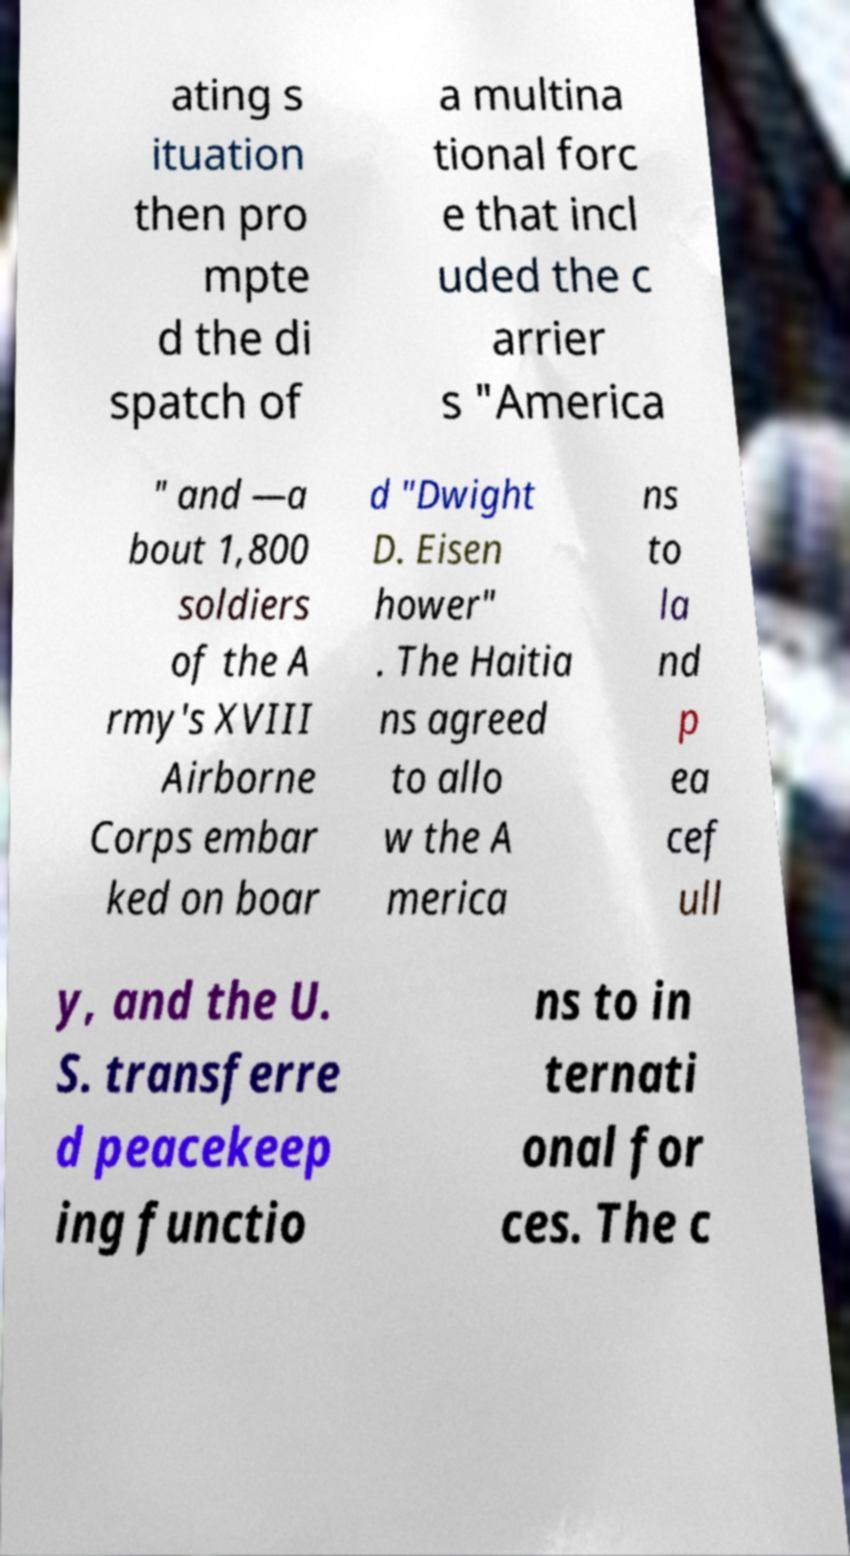Please identify and transcribe the text found in this image. ating s ituation then pro mpte d the di spatch of a multina tional forc e that incl uded the c arrier s "America " and —a bout 1,800 soldiers of the A rmy's XVIII Airborne Corps embar ked on boar d "Dwight D. Eisen hower" . The Haitia ns agreed to allo w the A merica ns to la nd p ea cef ull y, and the U. S. transferre d peacekeep ing functio ns to in ternati onal for ces. The c 